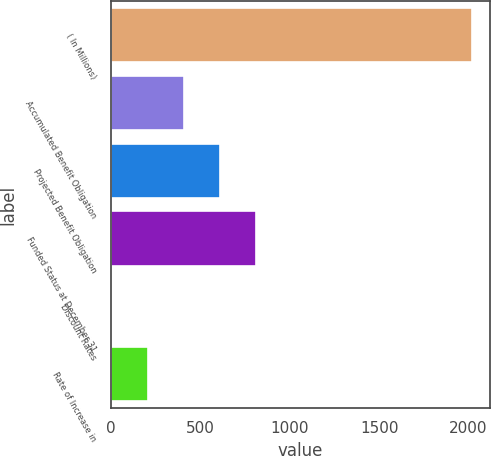<chart> <loc_0><loc_0><loc_500><loc_500><bar_chart><fcel>( In Millions)<fcel>Accumulated Benefit Obligation<fcel>Projected Benefit Obligation<fcel>Funded Status at December 31<fcel>Discount Rates<fcel>Rate of Increase in<nl><fcel>2017<fcel>406.43<fcel>607.75<fcel>809.07<fcel>3.79<fcel>205.11<nl></chart> 